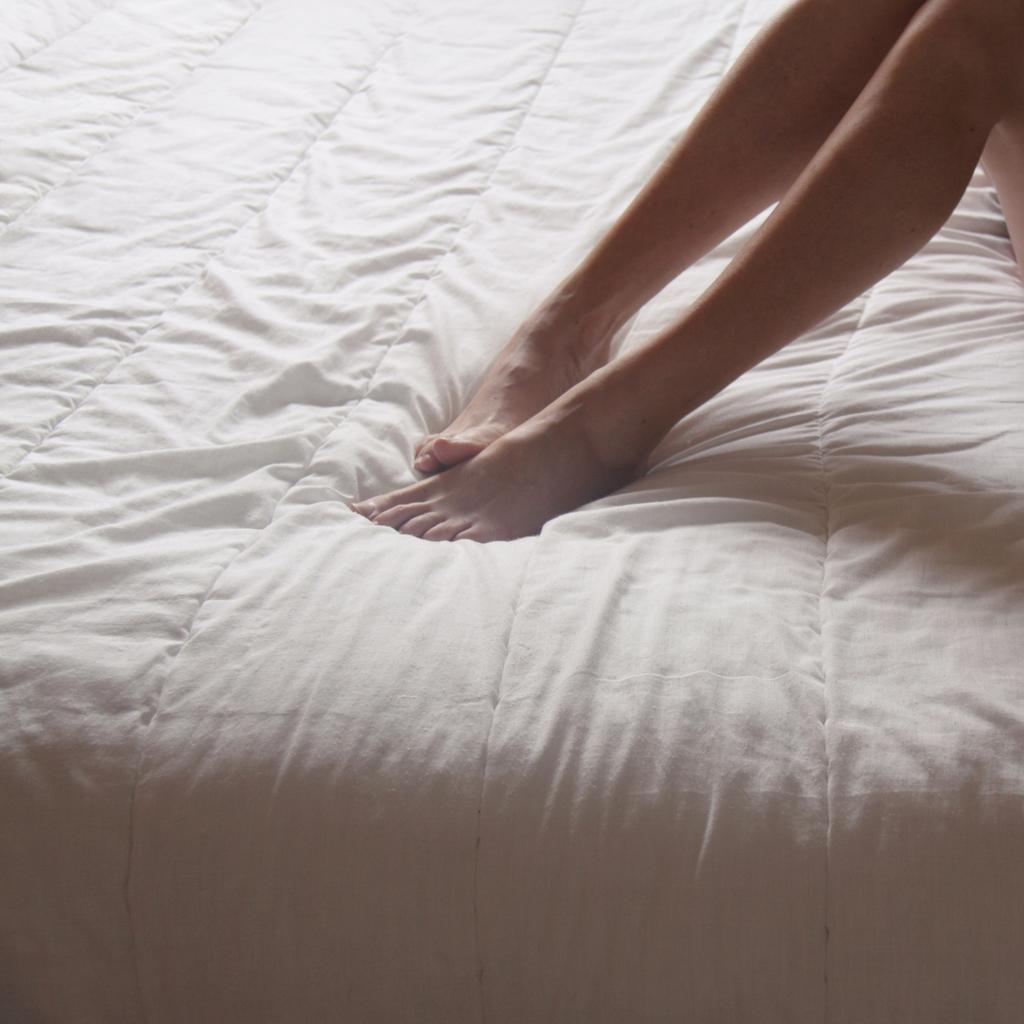What body parts are visible in the image? There are person legs visible in the image. Where are the person legs located? The person legs are on a blanket. What is the blanket placed on? The blanket is on a bed. What type of watch is the dad wearing in the image? There is no watch or dad present in the image; it only shows person legs on a blanket on a bed. 